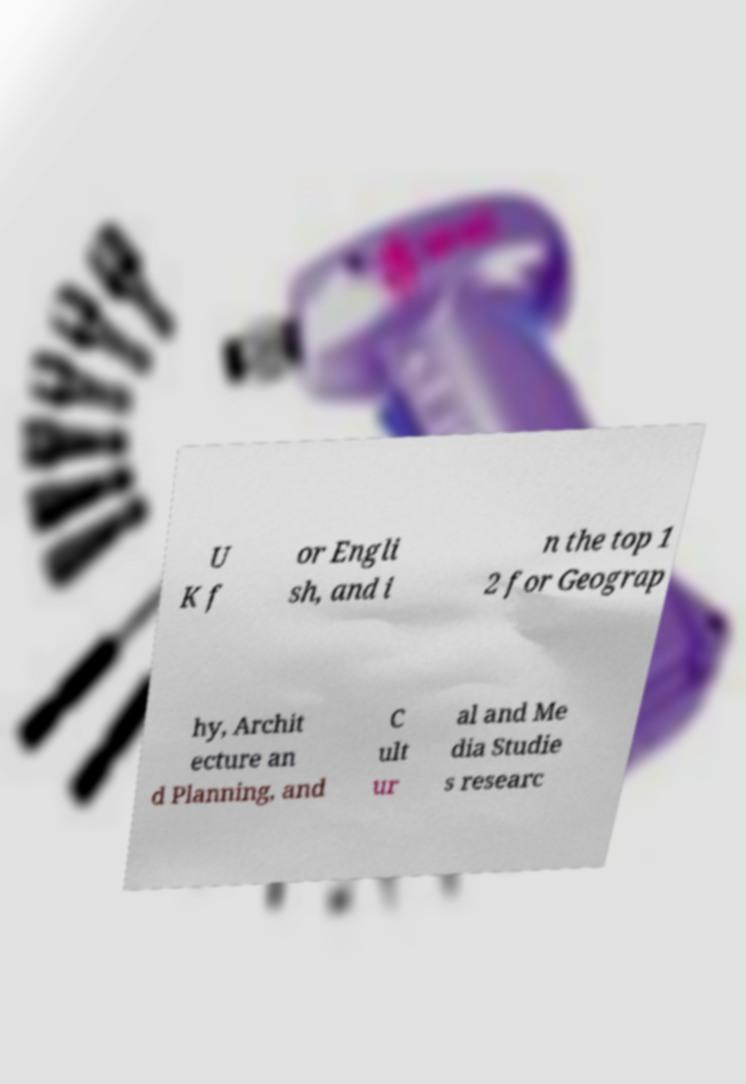There's text embedded in this image that I need extracted. Can you transcribe it verbatim? U K f or Engli sh, and i n the top 1 2 for Geograp hy, Archit ecture an d Planning, and C ult ur al and Me dia Studie s researc 